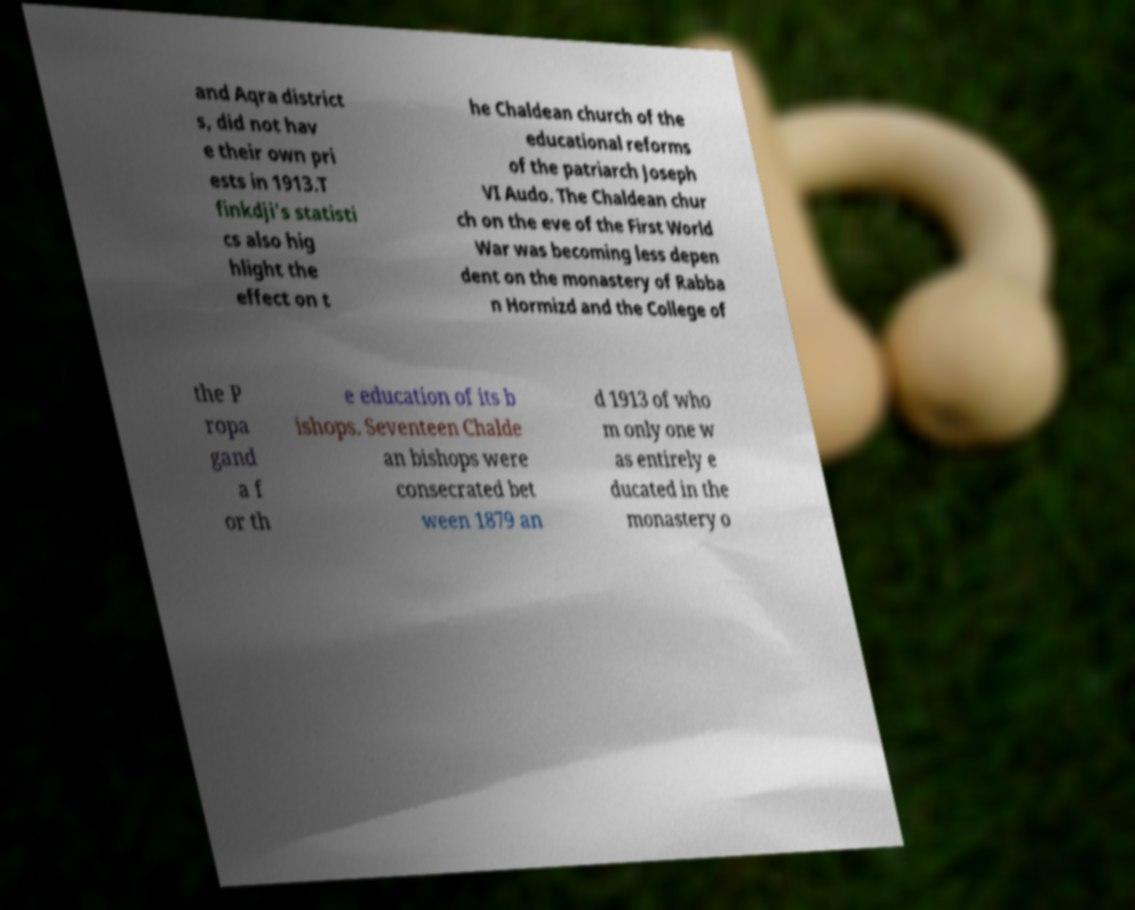Could you assist in decoding the text presented in this image and type it out clearly? and Aqra district s, did not hav e their own pri ests in 1913.T finkdji's statisti cs also hig hlight the effect on t he Chaldean church of the educational reforms of the patriarch Joseph VI Audo. The Chaldean chur ch on the eve of the First World War was becoming less depen dent on the monastery of Rabba n Hormizd and the College of the P ropa gand a f or th e education of its b ishops. Seventeen Chalde an bishops were consecrated bet ween 1879 an d 1913 of who m only one w as entirely e ducated in the monastery o 